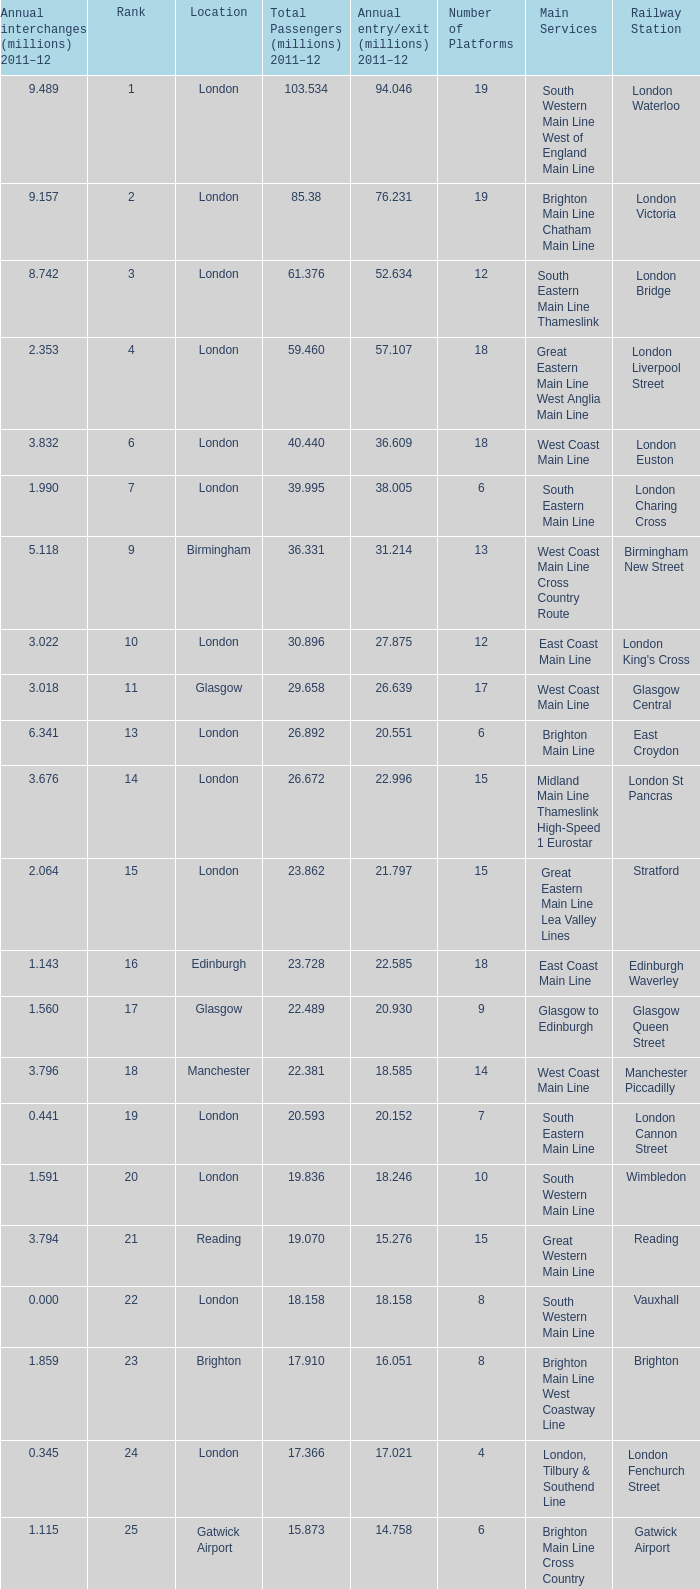Which location has 103.534 million passengers in 2011-12?  London. 